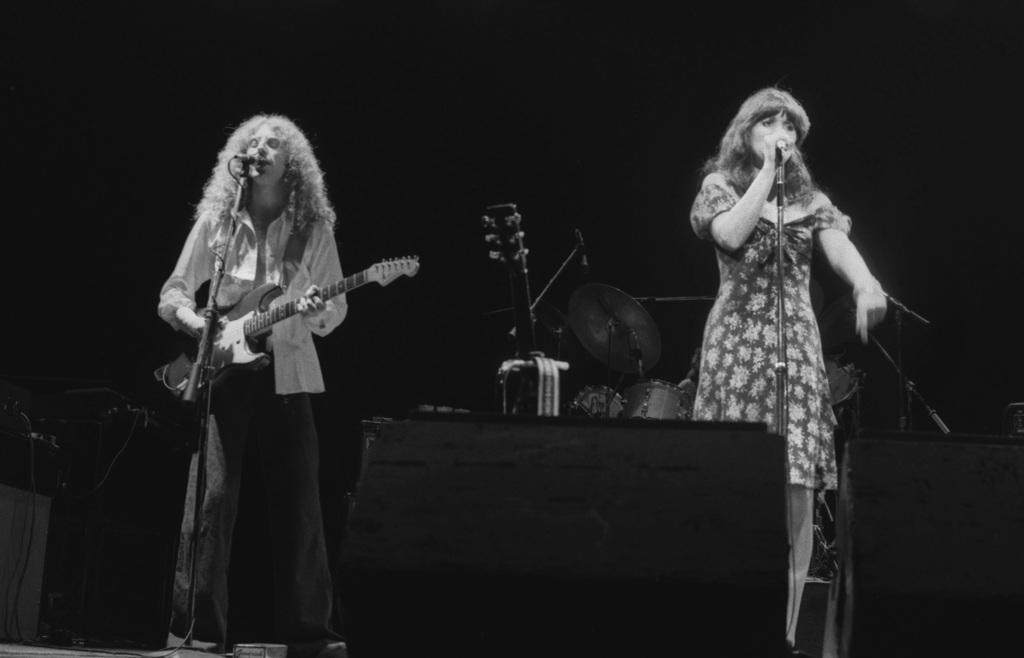In one or two sentences, can you explain what this image depicts? In the image we can see there is are two people who are standing on stage and a man who is holding guitar in his hand. 